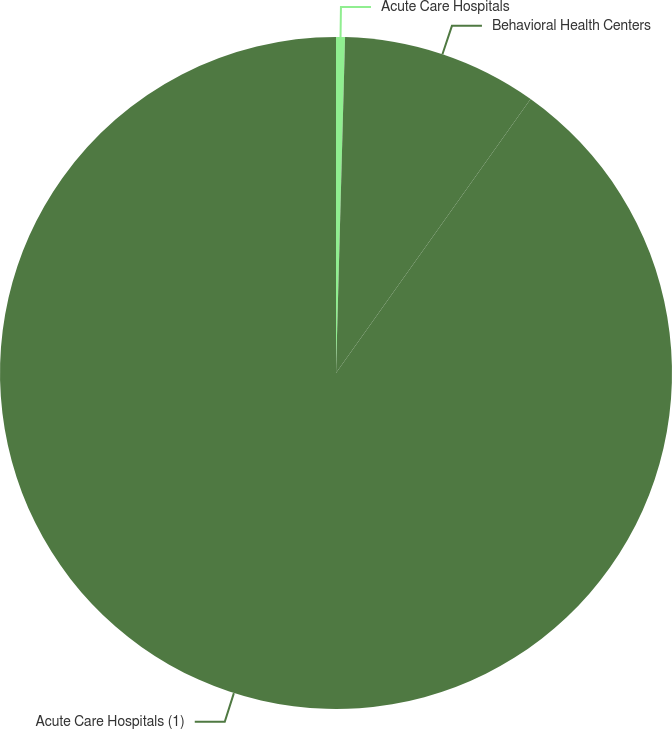Convert chart to OTSL. <chart><loc_0><loc_0><loc_500><loc_500><pie_chart><fcel>Acute Care Hospitals<fcel>Behavioral Health Centers<fcel>Acute Care Hospitals (1)<nl><fcel>0.43%<fcel>9.4%<fcel>90.17%<nl></chart> 